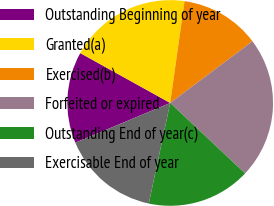<chart> <loc_0><loc_0><loc_500><loc_500><pie_chart><fcel>Outstanding Beginning of year<fcel>Granted(a)<fcel>Exercised(b)<fcel>Forfeited or expired<fcel>Outstanding End of year(c)<fcel>Exercisable End of year<nl><fcel>14.37%<fcel>19.17%<fcel>12.53%<fcel>22.26%<fcel>16.32%<fcel>15.35%<nl></chart> 